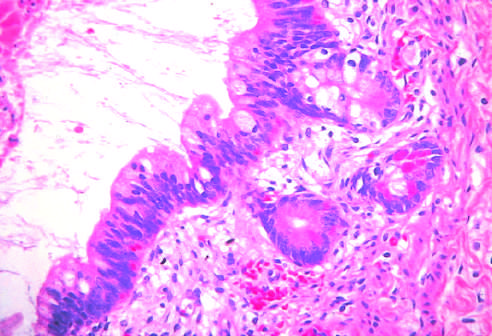do hepatocytes contain mature cells from endodermal, mesodermal, and ectodermal lines?
Answer the question using a single word or phrase. No 